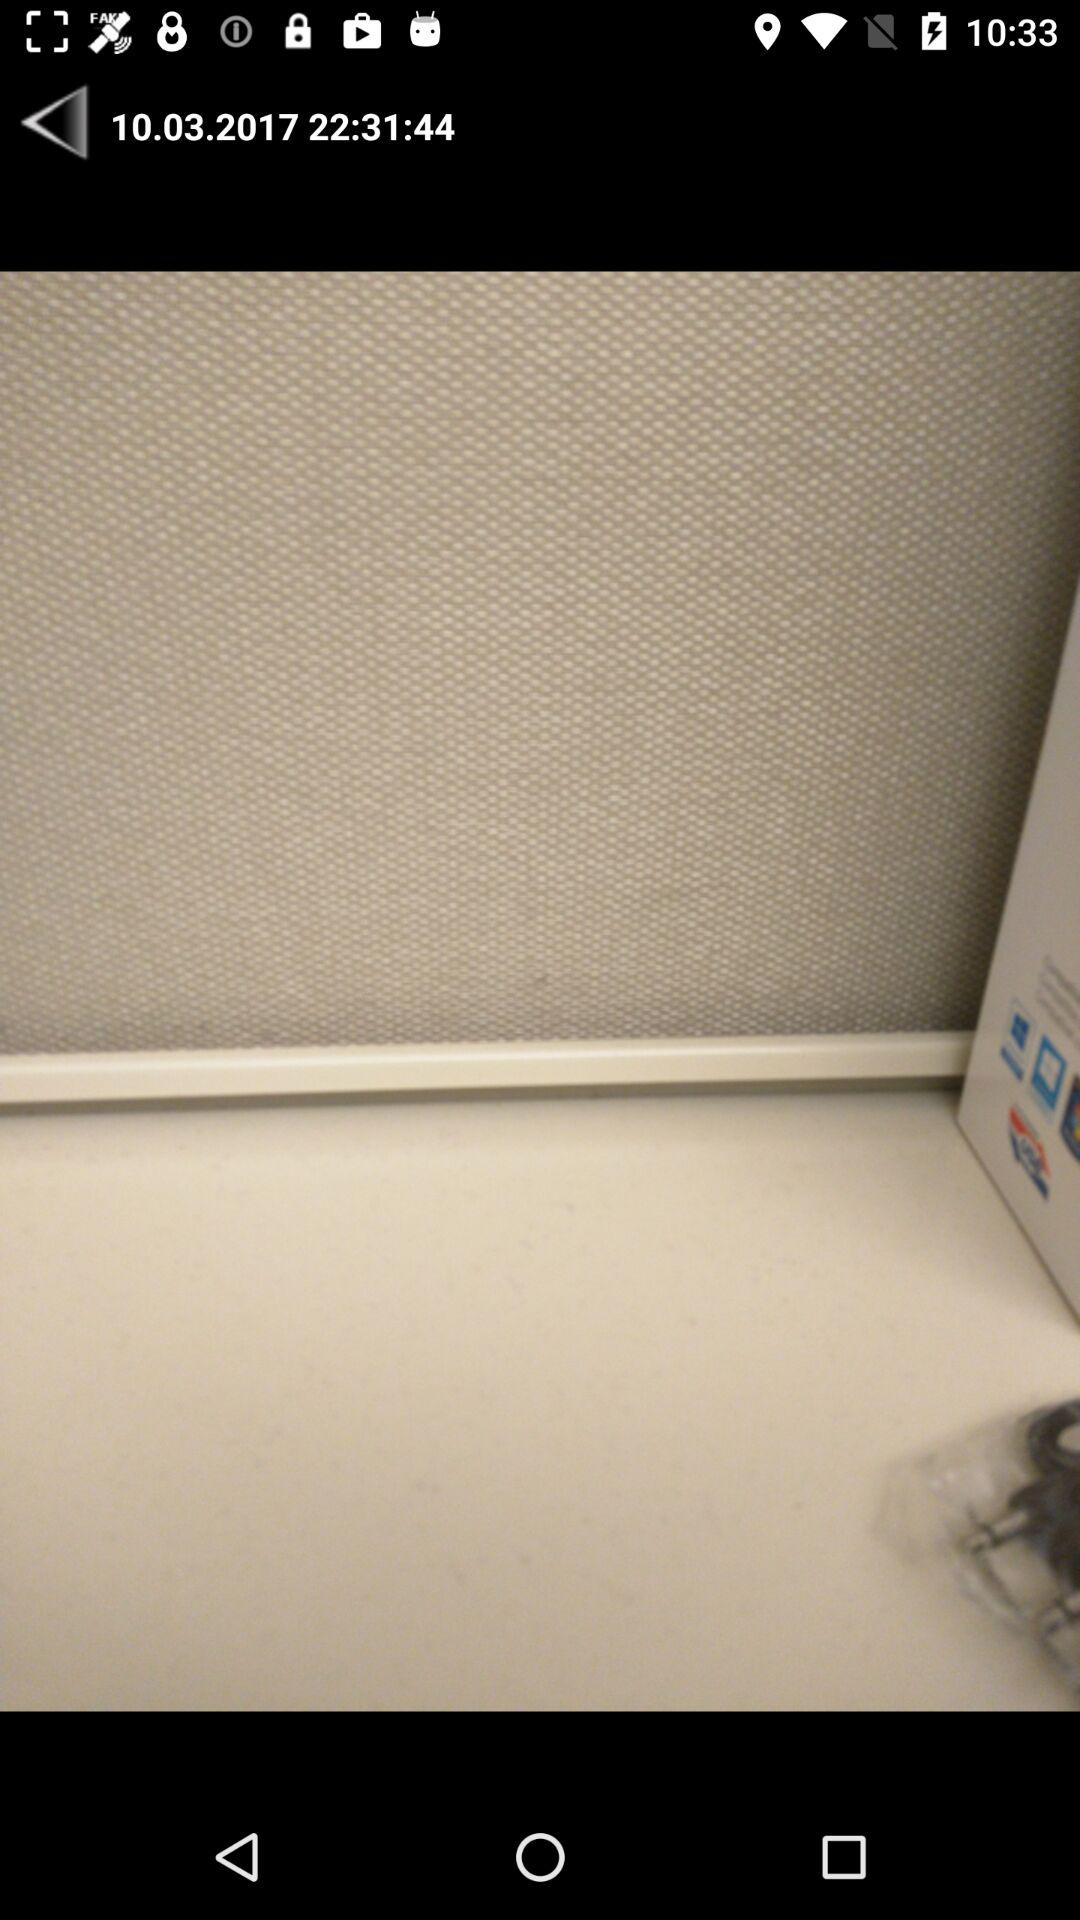What is the date? The date is 10.03.2017. 